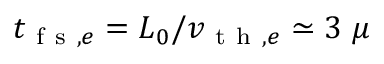Convert formula to latex. <formula><loc_0><loc_0><loc_500><loc_500>t _ { f s , e } = L _ { 0 } / v _ { t h , e } \simeq 3 \mu</formula> 